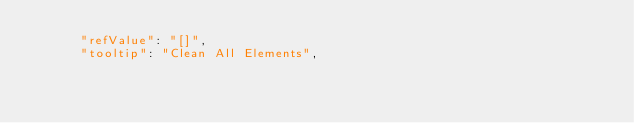Convert code to text. <code><loc_0><loc_0><loc_500><loc_500><_JavaScript_>      "refValue": "[]",
      "tooltip": "Clean All Elements",</code> 